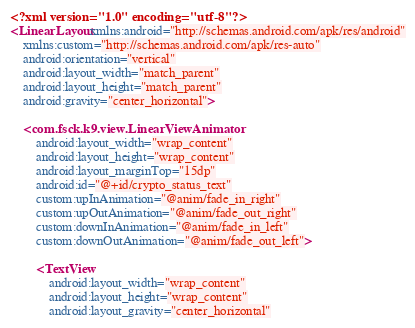<code> <loc_0><loc_0><loc_500><loc_500><_XML_><?xml version="1.0" encoding="utf-8"?>
<LinearLayout xmlns:android="http://schemas.android.com/apk/res/android"
    xmlns:custom="http://schemas.android.com/apk/res-auto"
    android:orientation="vertical"
    android:layout_width="match_parent"
    android:layout_height="match_parent"
    android:gravity="center_horizontal">

    <com.fsck.k9.view.LinearViewAnimator
        android:layout_width="wrap_content"
        android:layout_height="wrap_content"
        android:layout_marginTop="15dp"
        android:id="@+id/crypto_status_text"
        custom:upInAnimation="@anim/fade_in_right"
        custom:upOutAnimation="@anim/fade_out_right"
        custom:downInAnimation="@anim/fade_in_left"
        custom:downOutAnimation="@anim/fade_out_left">

        <TextView
            android:layout_width="wrap_content"
            android:layout_height="wrap_content"
            android:layout_gravity="center_horizontal"</code> 